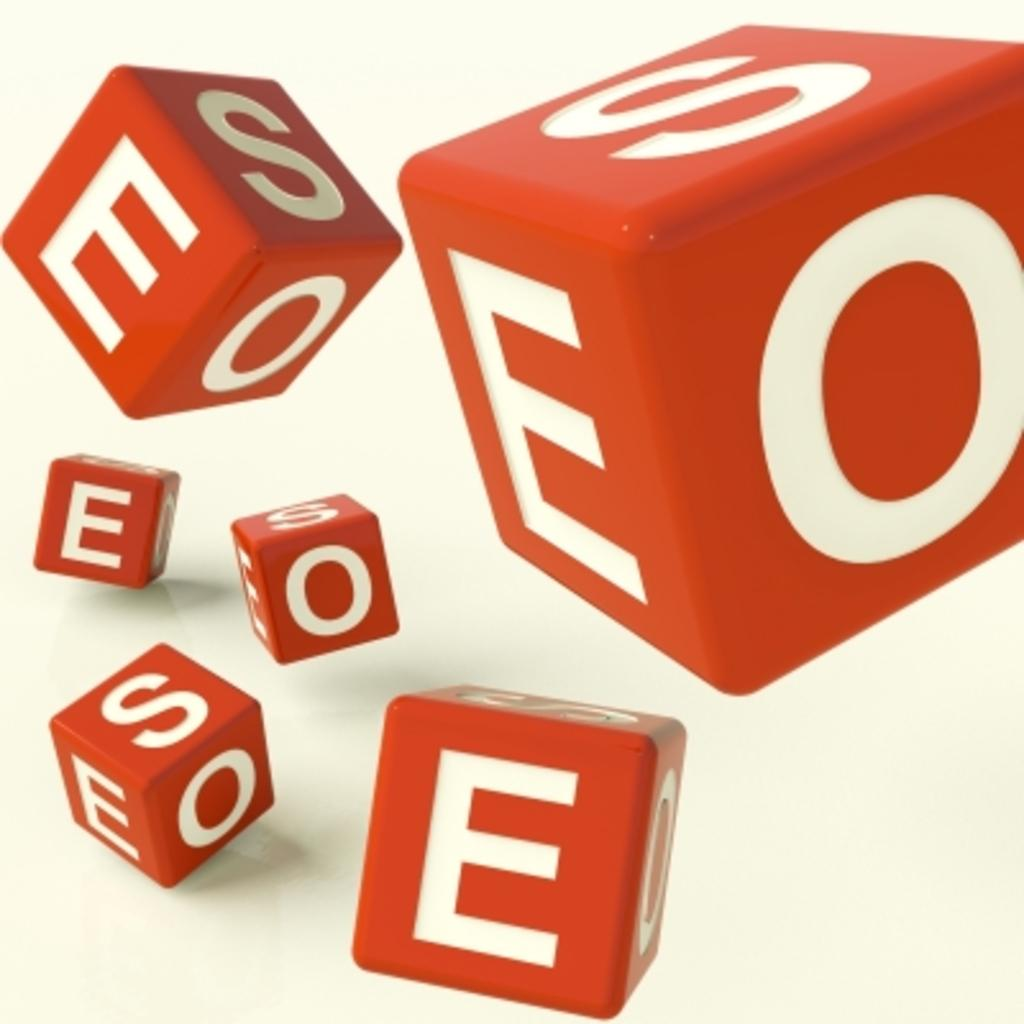What objects are present in the image? There are dice in the image. What is written on the dice? There are letters on the dice. What can be seen in the background of the image? The background of the image features a plane. What type of beast can be seen grazing in the background of the image? There is no beast present in the image; the background features a plane. What shocking event occurs in the image? There is no shocking event depicted in the image; it features dice with letters and a plane in the background. 